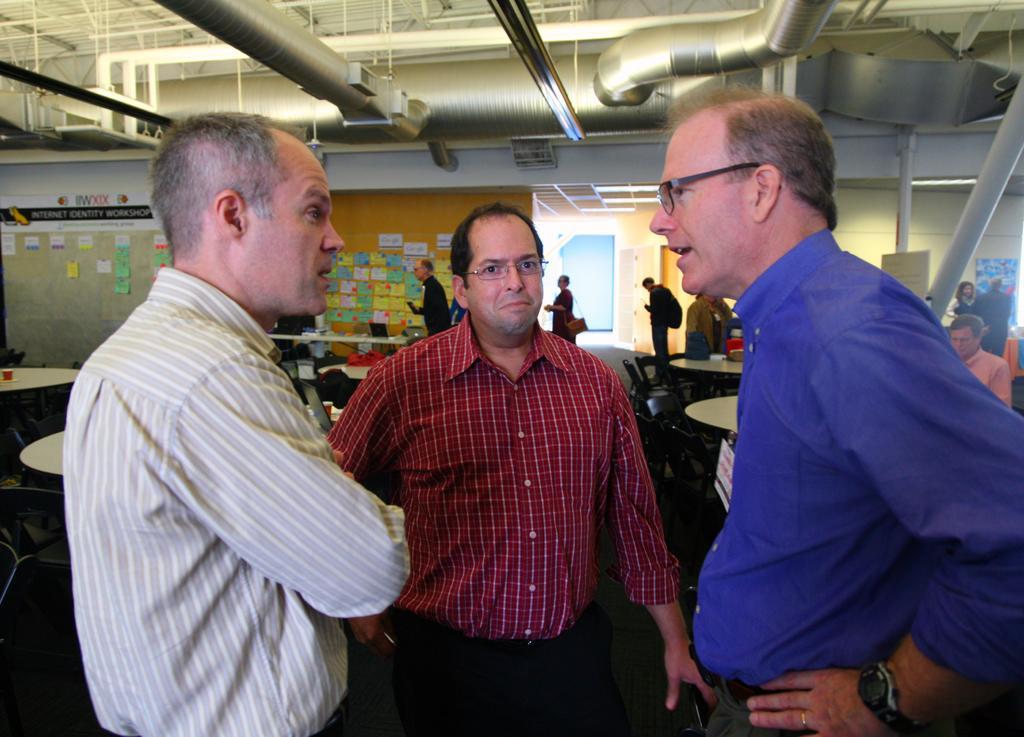Can you describe this image briefly? There are three men standing and talking to each other. These are the tables and chairs. I can see papers attached to the wall. There are few people walking. I can see a laptop, which is placed on the table. These are the pipes, which are on the roof. This looks like a pole. 